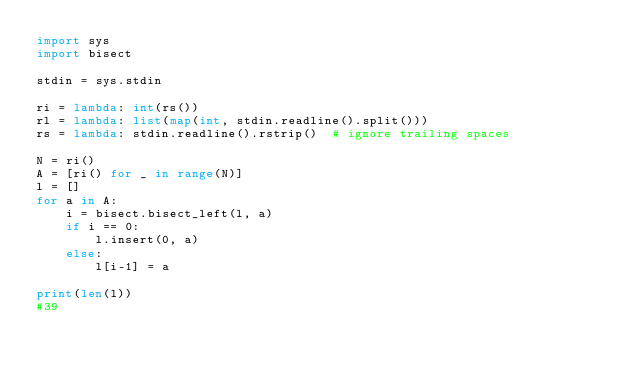<code> <loc_0><loc_0><loc_500><loc_500><_Python_>import sys
import bisect

stdin = sys.stdin
 
ri = lambda: int(rs())
rl = lambda: list(map(int, stdin.readline().split()))
rs = lambda: stdin.readline().rstrip()  # ignore trailing spaces

N = ri()
A = [ri() for _ in range(N)]
l = []
for a in A:
    i = bisect.bisect_left(l, a)
    if i == 0:
        l.insert(0, a)
    else:
        l[i-1] = a

print(len(l))
#39
</code> 